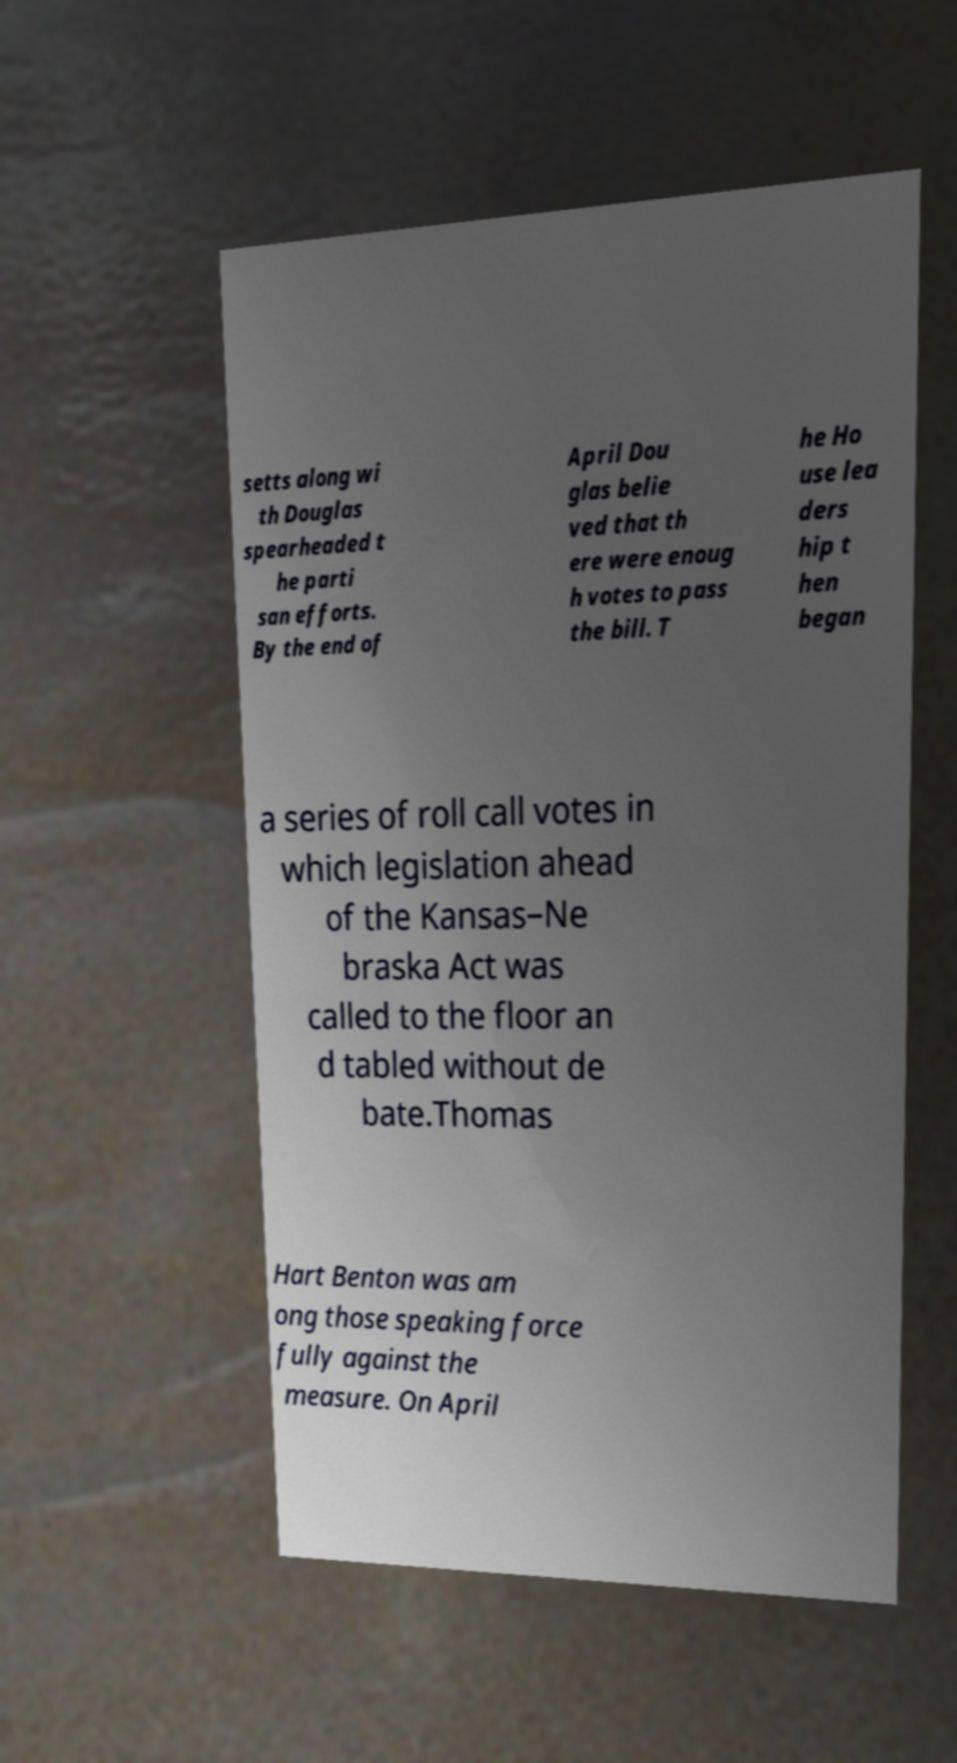What messages or text are displayed in this image? I need them in a readable, typed format. setts along wi th Douglas spearheaded t he parti san efforts. By the end of April Dou glas belie ved that th ere were enoug h votes to pass the bill. T he Ho use lea ders hip t hen began a series of roll call votes in which legislation ahead of the Kansas–Ne braska Act was called to the floor an d tabled without de bate.Thomas Hart Benton was am ong those speaking force fully against the measure. On April 